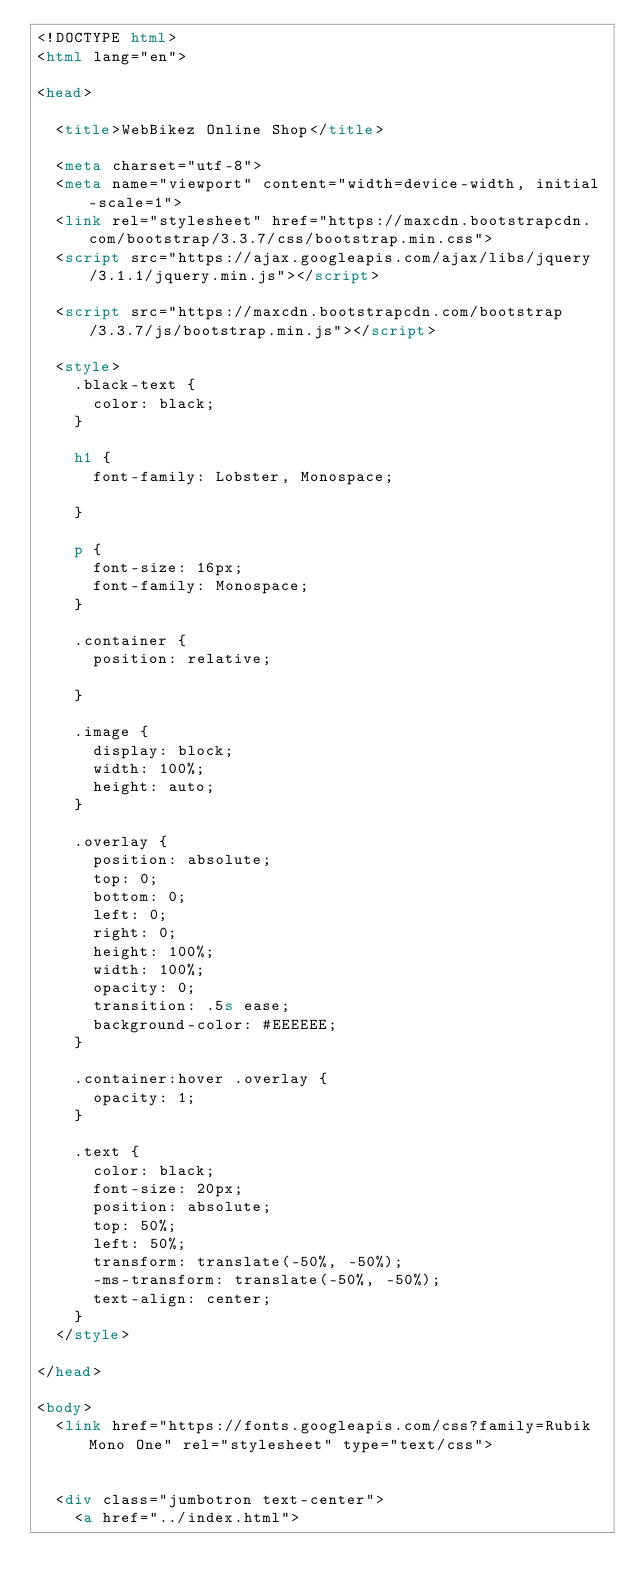Convert code to text. <code><loc_0><loc_0><loc_500><loc_500><_HTML_><!DOCTYPE html>
<html lang="en">

<head>

  <title>WebBikez Online Shop</title>

  <meta charset="utf-8">
  <meta name="viewport" content="width=device-width, initial-scale=1">
  <link rel="stylesheet" href="https://maxcdn.bootstrapcdn.com/bootstrap/3.3.7/css/bootstrap.min.css">
  <script src="https://ajax.googleapis.com/ajax/libs/jquery/3.1.1/jquery.min.js"></script>

  <script src="https://maxcdn.bootstrapcdn.com/bootstrap/3.3.7/js/bootstrap.min.js"></script>

  <style>
    .black-text {
      color: black;
    }

    h1 {
      font-family: Lobster, Monospace;

    }

    p {
      font-size: 16px;
      font-family: Monospace;
    }

    .container {
      position: relative;

    }

    .image {
      display: block;
      width: 100%;
      height: auto;
    }

    .overlay {
      position: absolute;
      top: 0;
      bottom: 0;
      left: 0;
      right: 0;
      height: 100%;
      width: 100%;
      opacity: 0;
      transition: .5s ease;
      background-color: #EEEEEE;
    }

    .container:hover .overlay {
      opacity: 1;
    }

    .text {
      color: black;
      font-size: 20px;
      position: absolute;
      top: 50%;
      left: 50%;
      transform: translate(-50%, -50%);
      -ms-transform: translate(-50%, -50%);
      text-align: center;
    }
  </style>

</head>

<body>
  <link href="https://fonts.googleapis.com/css?family=Rubik Mono One" rel="stylesheet" type="text/css">


  <div class="jumbotron text-center">
    <a href="../index.html"></code> 